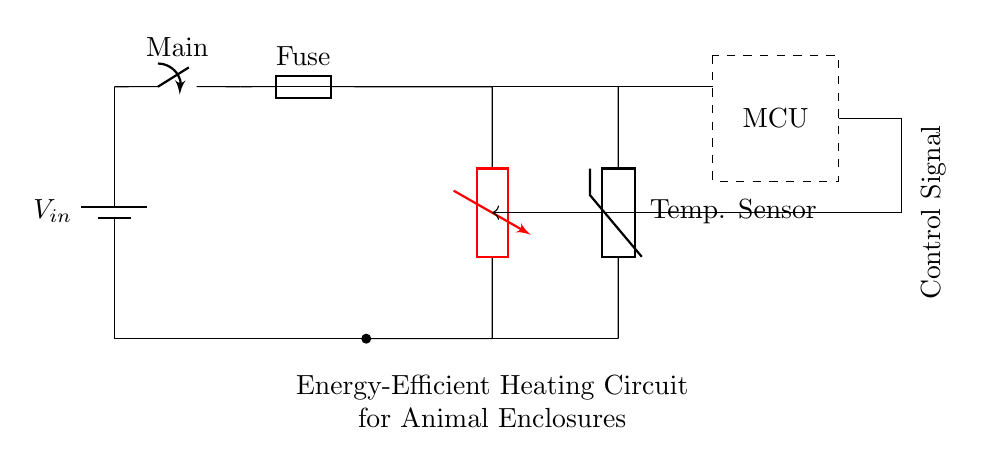What is the main power source in this circuit? The main power source is the battery, which provides the input voltage represented as V_in. This is indicated in the top left corner of the circuit diagram.
Answer: battery What type of module is used for heating? The heating element in this circuit is a thermoelectric module, noted in the diagram as "Thermoelectric Module" and labeled with TEM. This component is responsible for converting electrical energy into thermal energy.
Answer: thermoelectric module What type of sensor is present in the circuit? The circuit includes a temperature sensor, depicted as a thermistor, which is utilized to monitor the temperature of the environment within animal enclosures. This is labeled as "Temp. Sensor" in the diagram.
Answer: thermistor How is the control signal transmitted in this circuit? The control signal is transmitted from the microcontroller, indicated in a dashed rectangle, and shown by the arrow that directs the control signal towards the thermoelectric module. This shows that the microcontroller is responsible for managing the operation of the heating element.
Answer: through an arrow from the microcontroller What protective component is included in the circuit? The circuit features a fuse, which is present between the main switch and the thermoelectric module. The fuse is a safety device designed to protect the circuit from excessive current, thus preventing potential damage.
Answer: fuse What is the direction of the control signal in this circuit? The control signal flows from the microcontroller towards the thermoelectric module, represented by an arrow indicating the direction in which the control signal is intended to travel. This is crucial for the operation of the heating system based on temperature readings.
Answer: from microcontroller to thermoelectric module 